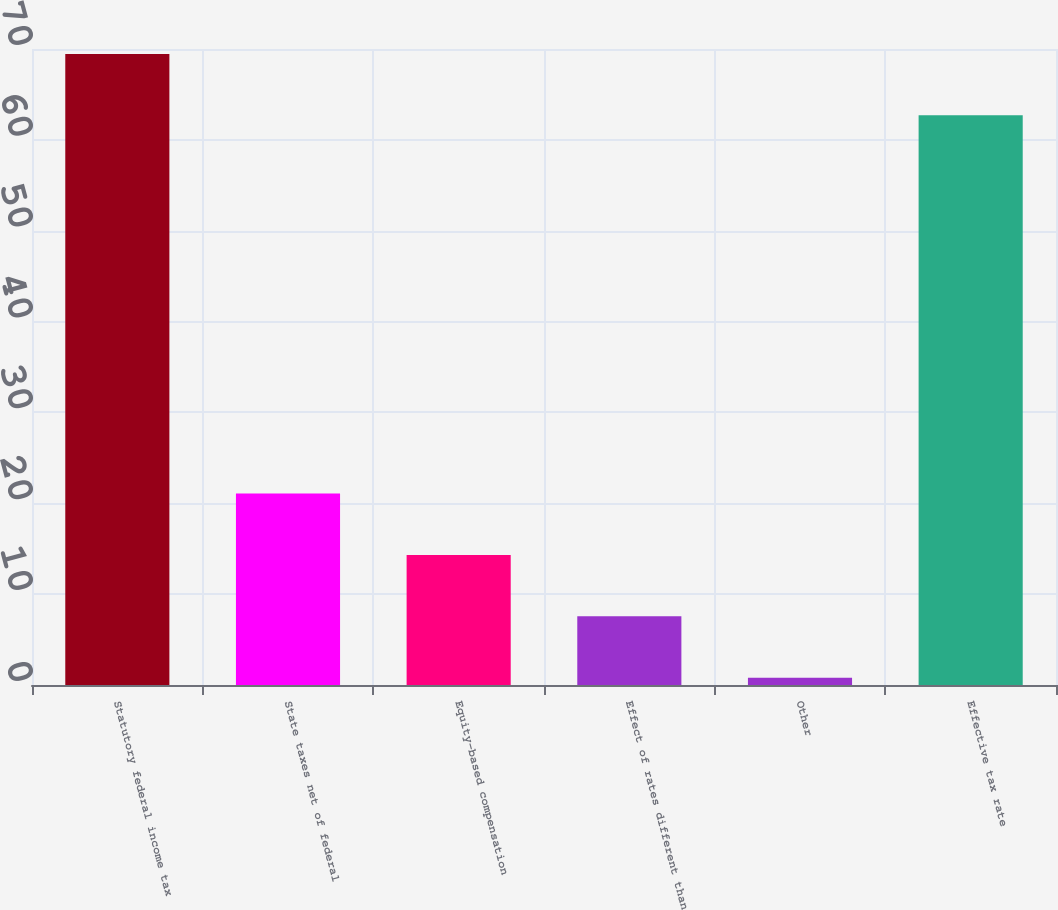Convert chart to OTSL. <chart><loc_0><loc_0><loc_500><loc_500><bar_chart><fcel>Statutory federal income tax<fcel>State taxes net of federal<fcel>Equity-based compensation<fcel>Effect of rates different than<fcel>Other<fcel>Effective tax rate<nl><fcel>69.46<fcel>21.08<fcel>14.32<fcel>7.56<fcel>0.8<fcel>62.7<nl></chart> 